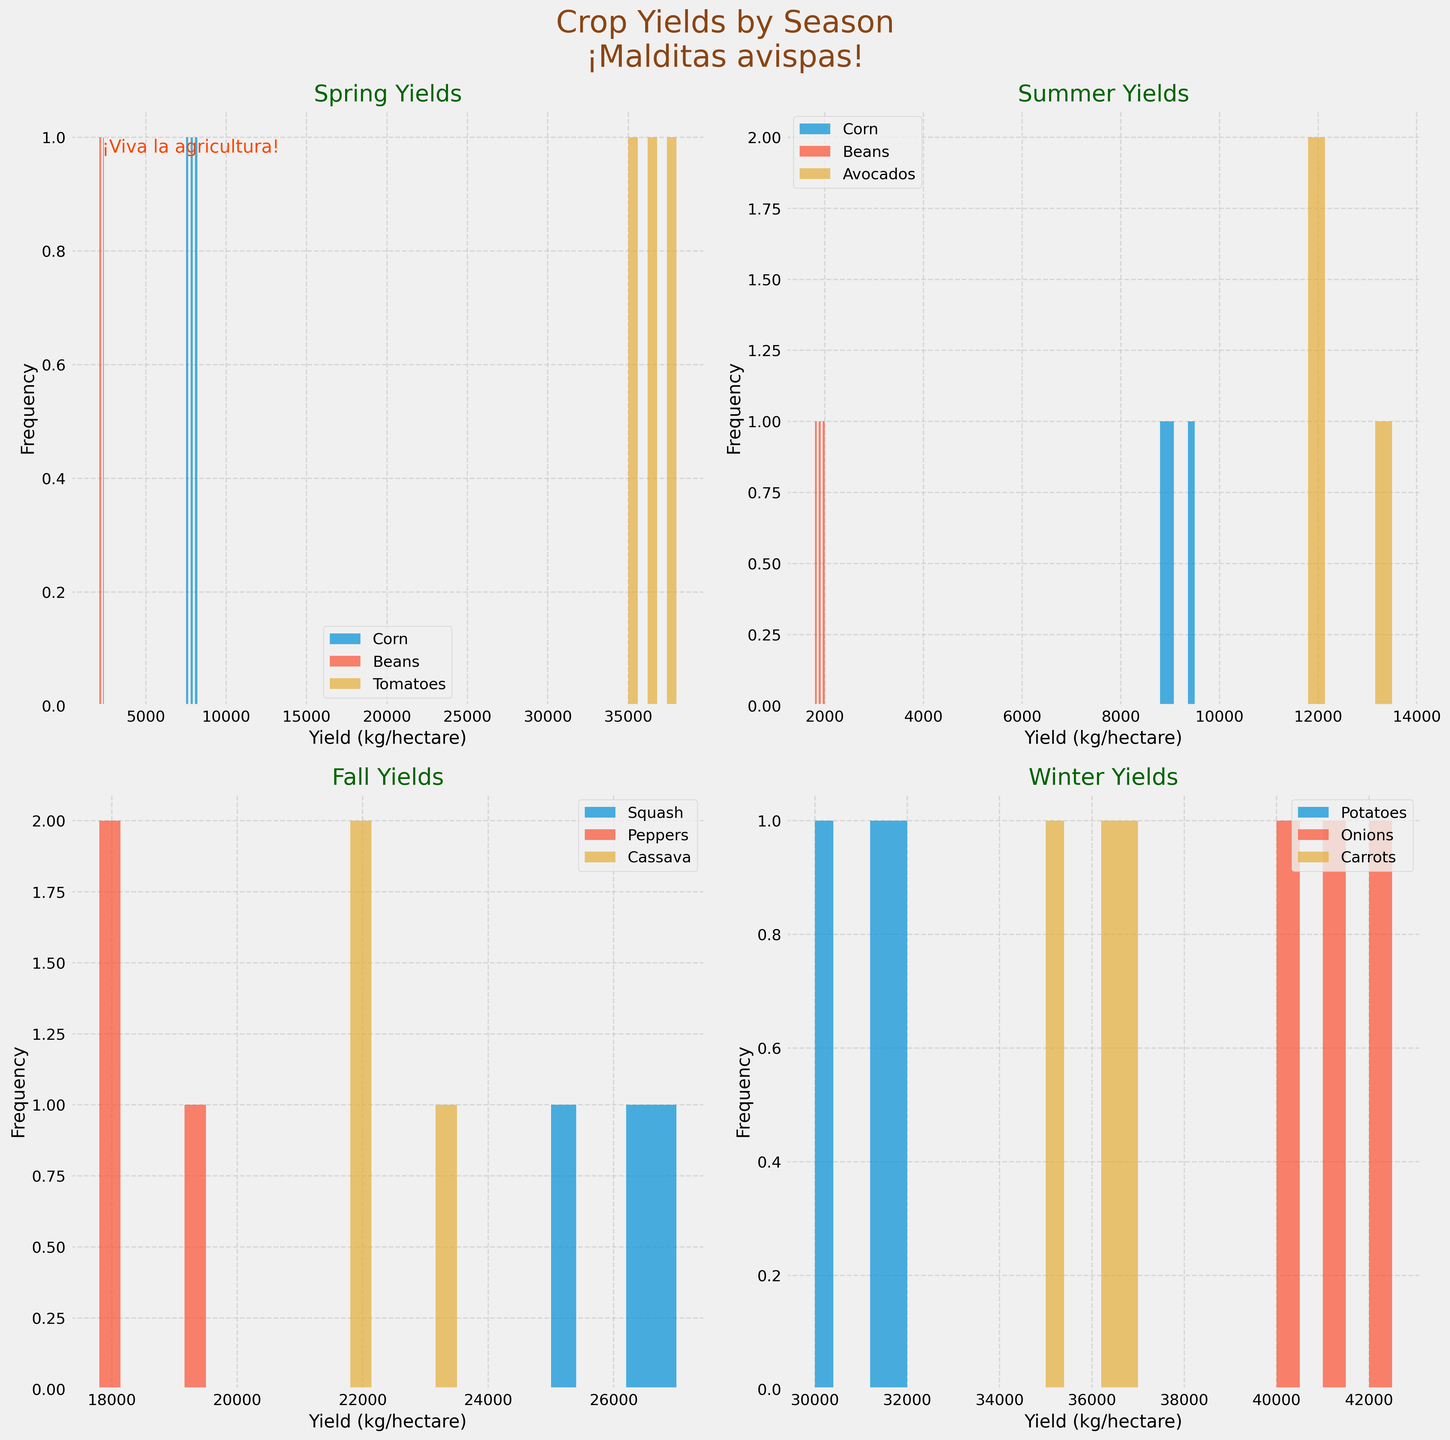What is the title of the figure? The title of the figure is prominently displayed at the top of the plot in a larger font size. Looking at the title, it reads "Crop Yields by Season\n¡Malditas avispas!"
Answer: Crop Yields by Season\n¡Malditas avispas! What season has the crop with the highest average yield? To determine which season has the crop with the highest average yield, look at each subplot and identify the crop with the highest average yield in kg/hectare. For Winter, Onions have a high average yield of around 41500 kg/hectare.
Answer: Winter Which crop appears in the Spring season with the most spread out yields? For Spring, examine the histograms and see which crop's bars are spread over a wider range. Tomatoes are spread over a wider range compared to Corn and Beans.
Answer: Tomatoes Which crop has the highest frequency of yields around 32000 kg per hectare? Look at the histograms to spot which crop has multiple bars around the 32000 kg/hectare mark. Potatoes in Winter show multiple high bars around 32000 kg/hectare.
Answer: Potatoes What is the average yield for the Summer Corn crop? Summer Corn yields are 9000, 9500, and 8800. Sum these values (9000 + 9500 + 8800 = 27300) and divide by the number of data points (27300 / 3).
Answer: 9100 Compare the maximum yields of Beans in Spring and Summer. Which one is higher and by how much? The maximum yield of Beans in Spring is 2400 kg/hectare and in Summer is 2000 kg/hectare. The difference is 2400 - 2000.
Answer: Spring, 400 How does the distribution of yields for Fall Squash compare to Fall Peppers? Examine the histograms for Squash and Peppers in the Fall season. Squash yields (25000-27000 kg/hectare) tend to be higher and more spread out compared to Peppers (17800-19500 kg/hectare).
Answer: Squash yields are higher and more spread out 